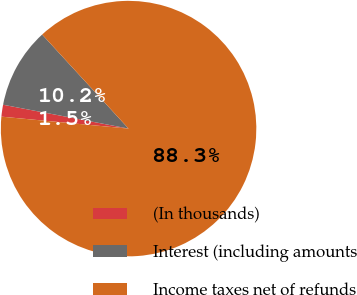Convert chart. <chart><loc_0><loc_0><loc_500><loc_500><pie_chart><fcel>(In thousands)<fcel>Interest (including amounts<fcel>Income taxes net of refunds<nl><fcel>1.5%<fcel>10.18%<fcel>88.31%<nl></chart> 